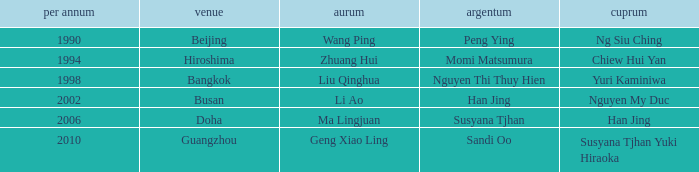What Gold has the Year of 1994? Zhuang Hui. 